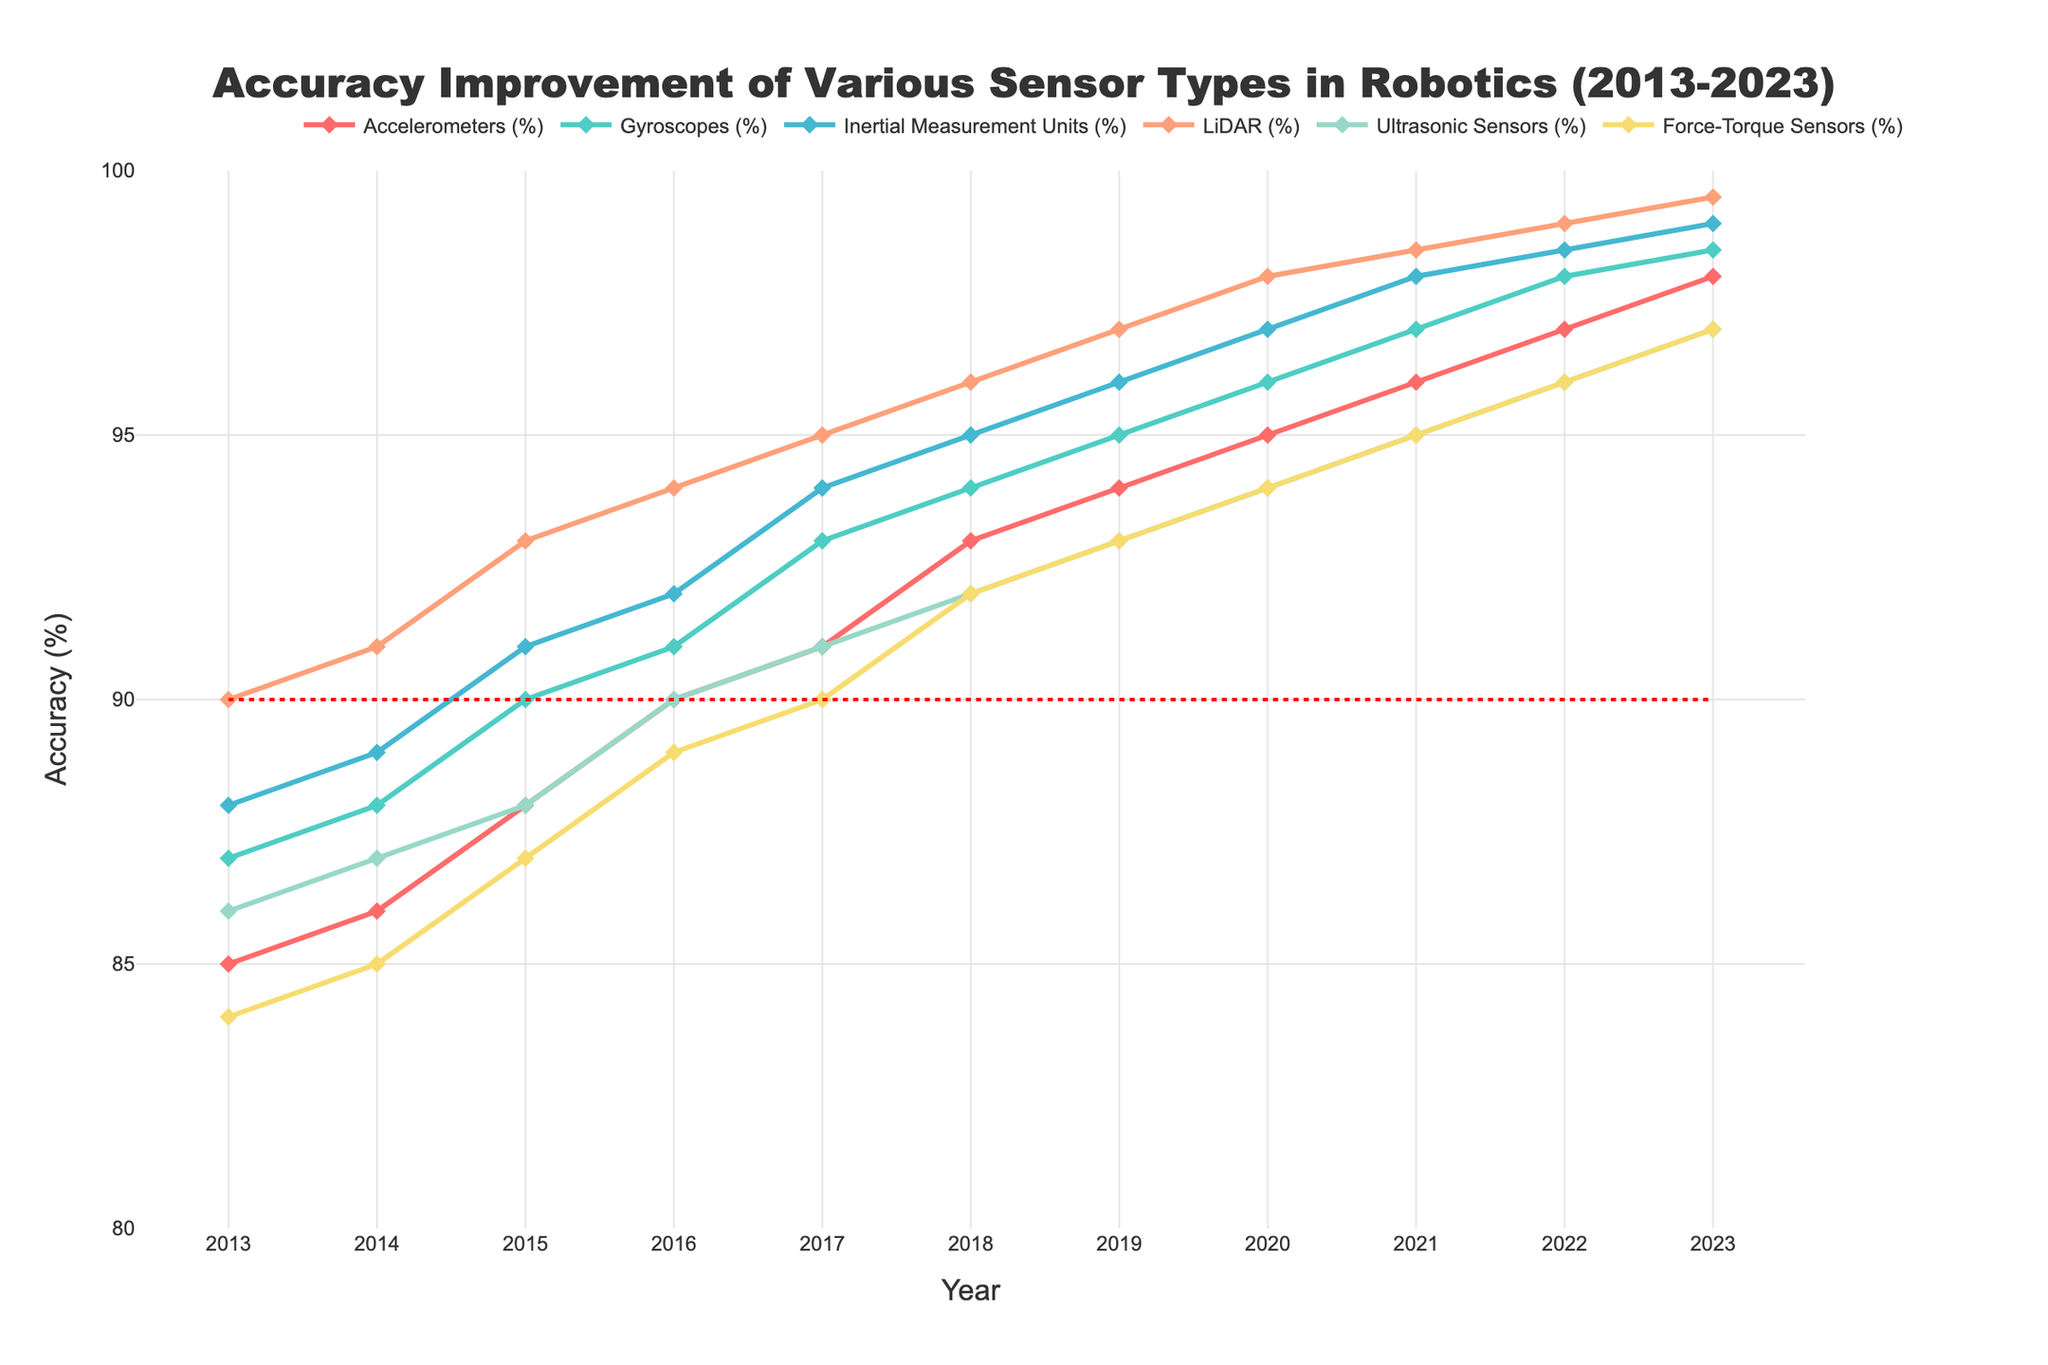What is the average accuracy of Gyroscopes across the decade? To find the average accuracy of Gyroscopes, sum the accuracies for each year (87 + 88 + 90 + 91 + 93 + 94 + 95 + 96 + 97 + 98.5) and then divide by 10. The total is 929.5, so the average is 929.5 / 10.
Answer: 92.95% Which sensor had the highest accuracy improvement between 2013 and 2023? To determine which sensor had the highest accuracy improvement, subtract the 2013 accuracy value from the 2023 accuracy value for each sensor. Inertial Measurement Units improved by 99 - 88 = 11%. This is the highest improvement among all sensors.
Answer: Inertial Measurement Units What is the difference in the 2023 accuracy between Accelerometers and Ultrasonic Sensors? In 2023, the accuracy of Accelerometers is 98% and Ultrasonic Sensors is 97%. Subtract the two values to find the difference: 98% - 97% = 1%.
Answer: 1% Which sensor consistently showed an accuracy higher than 95% from 2020 onwards? To find out which sensor consistently showed high accuracy, check the accuracy values from 2020 to 2023. LiDAR shows values of 98%, 98.5%, 99%, and 99.5%, which are all above 95%.
Answer: LiDAR How many sensors had accuracies above 90% in 2015? Checking the 2015 values, we see the accuracies are: Accelerometers (88%), Gyroscopes (90%), Inertial Measurement Units (91%), LiDAR (93%), Ultrasonic Sensors (88%), Force-Torque Sensors (87%). Three sensors (Gyroscopes, Inertial Measurement Units, and LiDAR) had accuracies above 90%.
Answer: 3 In which year did Accelerometers first exceed 90% accuracy? Reviewing the data, Accelerometers first exceeded 90% in 2016 with an accuracy of 90%.
Answer: 2016 Between 2018 and 2023, which sensor showed the least improvement in accuracy? Calculate the improvement for each sensor from 2018 to 2023 and compare. For example: Accelerometers improved from 93% to 98% (5%), Gyroscopes from 94% to 98.5% (4.5%), Ultrasonic Sensors from 92% to 97% (5%), Force-Torque Sensors from 92% to 97% (5%). Therefore, Gyroscopes showed the least improvement.
Answer: Gyroscopes What is the overall trend in the accuracy of LiDAR sensors from 2013 to 2023? By looking at LiDAR accuracy values over these years, it is evident that the trend is continuously increasing from 90% in 2013 to 99.5% in 2023.
Answer: Increasing Are there any sensors that crossed 95% accuracy in 2019? The accuracies in 2019 show that Gyroscopes (95%), Inertial Measurement Units (96%), and LiDAR (97%) all crossed 95%.
Answer: Yes 